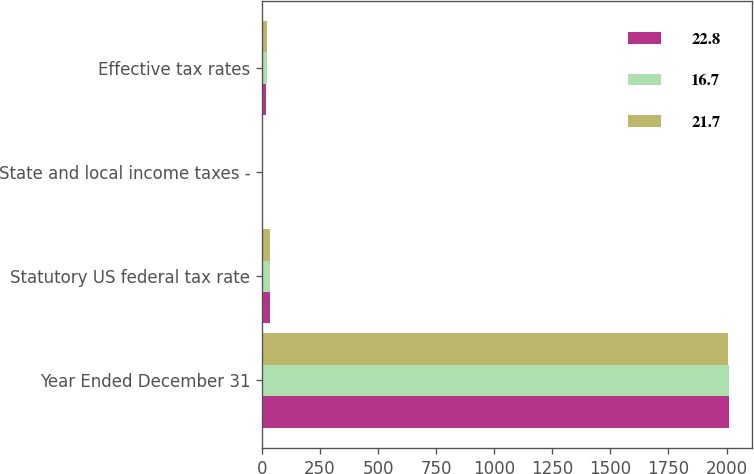Convert chart. <chart><loc_0><loc_0><loc_500><loc_500><stacked_bar_chart><ecel><fcel>Year Ended December 31<fcel>Statutory US federal tax rate<fcel>State and local income taxes -<fcel>Effective tax rates<nl><fcel>22.8<fcel>2010<fcel>35<fcel>0.6<fcel>16.7<nl><fcel>16.7<fcel>2009<fcel>35<fcel>0.7<fcel>22.8<nl><fcel>21.7<fcel>2008<fcel>35<fcel>0.8<fcel>21.7<nl></chart> 